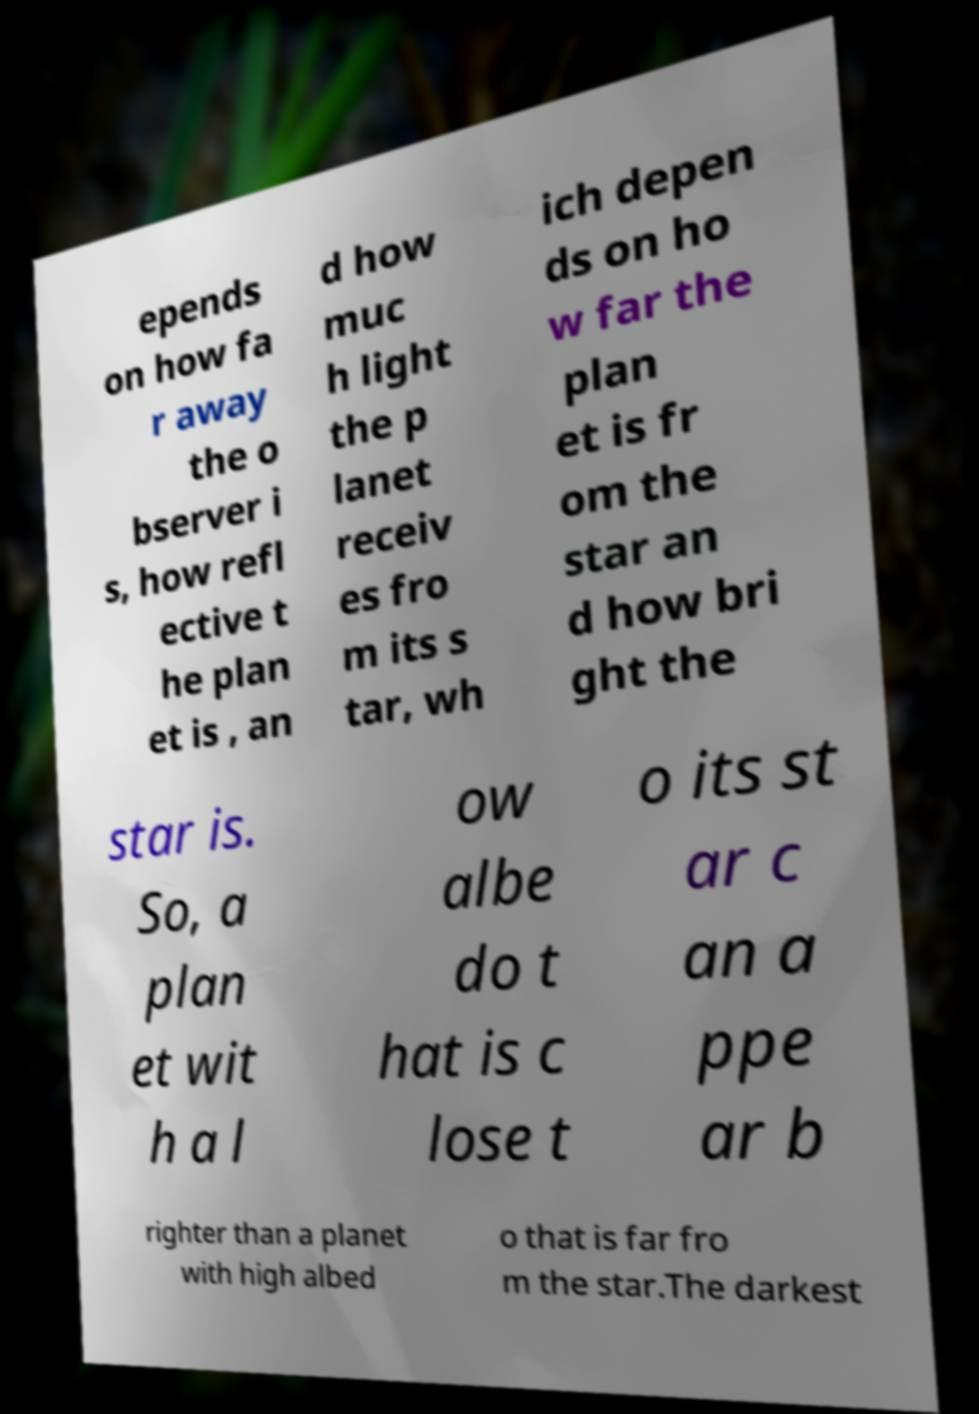Could you extract and type out the text from this image? epends on how fa r away the o bserver i s, how refl ective t he plan et is , an d how muc h light the p lanet receiv es fro m its s tar, wh ich depen ds on ho w far the plan et is fr om the star an d how bri ght the star is. So, a plan et wit h a l ow albe do t hat is c lose t o its st ar c an a ppe ar b righter than a planet with high albed o that is far fro m the star.The darkest 